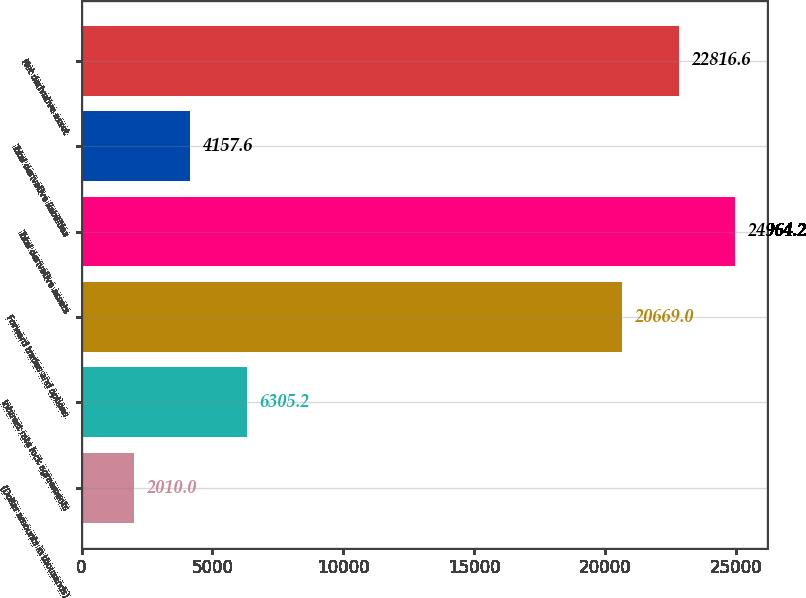Convert chart to OTSL. <chart><loc_0><loc_0><loc_500><loc_500><bar_chart><fcel>(Dollar amounts in thousands)<fcel>Interest rate lock agreements<fcel>Forward trades and options<fcel>Total derivative assets<fcel>Total derivative liabilities<fcel>Net derivative asset<nl><fcel>2010<fcel>6305.2<fcel>20669<fcel>24964.2<fcel>4157.6<fcel>22816.6<nl></chart> 